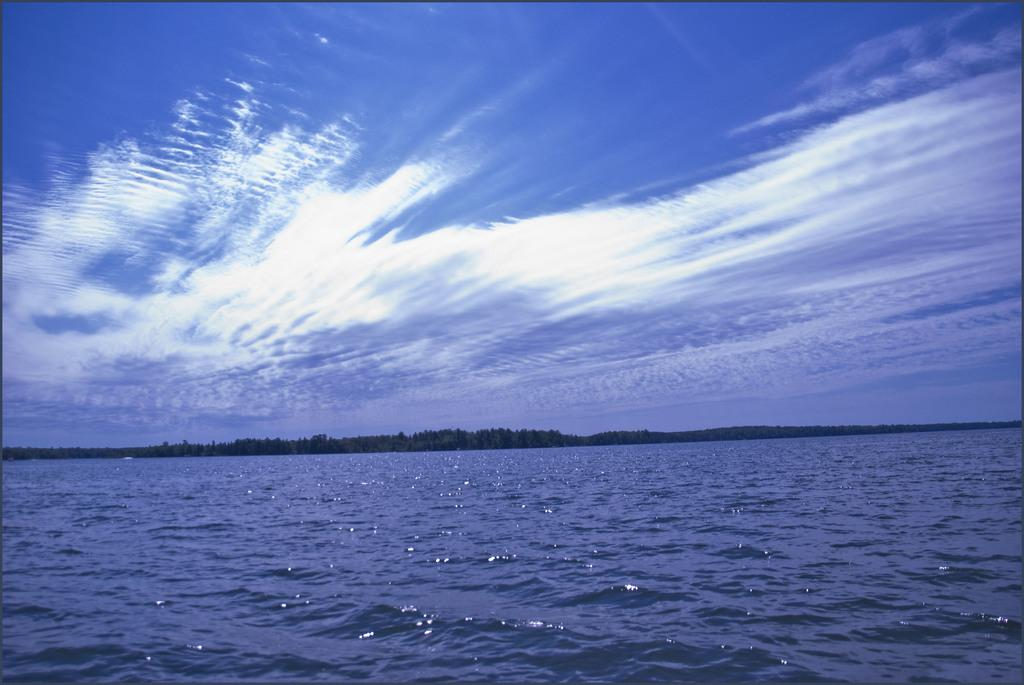What is present at the bottom of the image? There is water at the bottom of the image. What can be seen in the background of the image? There are objects in the background that resemble trees. What is visible at the top of the image? The sky is visible at the top of the image. How many oranges are hanging from the trees in the image? There are no oranges present in the image; it only features objects that resemble trees. What type of coat is being worn by the person in the image? There is no person present in the image, so it is not possible to determine what type of coat they might be wearing. 